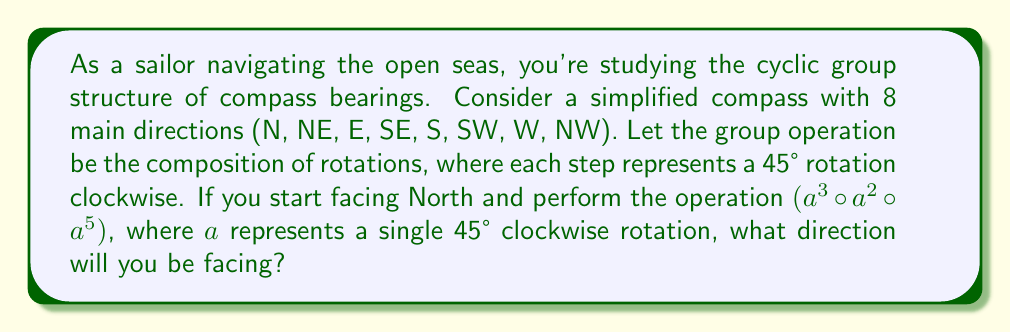Can you answer this question? Let's approach this step-by-step:

1) First, we need to understand the group structure:
   - The group has 8 elements, corresponding to the 8 compass directions.
   - The identity element is 0 rotations (staying in the same direction).
   - The group operation is composition of rotations, which is equivalent to addition modulo 8.

2) Now, let's break down the given operation $(a^3 \circ a^2 \circ a^5)$:
   - $a^3$ represents 3 steps clockwise
   - $a^2$ represents 2 steps clockwise
   - $a^5$ represents 5 steps clockwise

3) In a cyclic group, we can add the exponents:
   $$(a^3 \circ a^2 \circ a^5) = a^{3+2+5} = a^{10}$$

4) Since we're working with 8 directions, we can reduce this modulo 8:
   $$a^{10} \equiv a^2 \pmod{8}$$

5) $a^2$ represents 2 steps clockwise from North:
   N → NE → E

Therefore, after performing this operation, you will be facing East.
Answer: East 